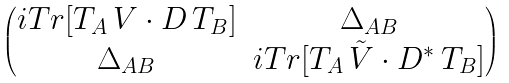Convert formula to latex. <formula><loc_0><loc_0><loc_500><loc_500>\begin{pmatrix} i T r [ T _ { A } \, V \cdot D \, T _ { B } ] & \Delta _ { A B } \\ \Delta _ { A B } & i T r [ T _ { A } \, \tilde { V } \cdot D ^ { * } \, T _ { B } ] \end{pmatrix}</formula> 